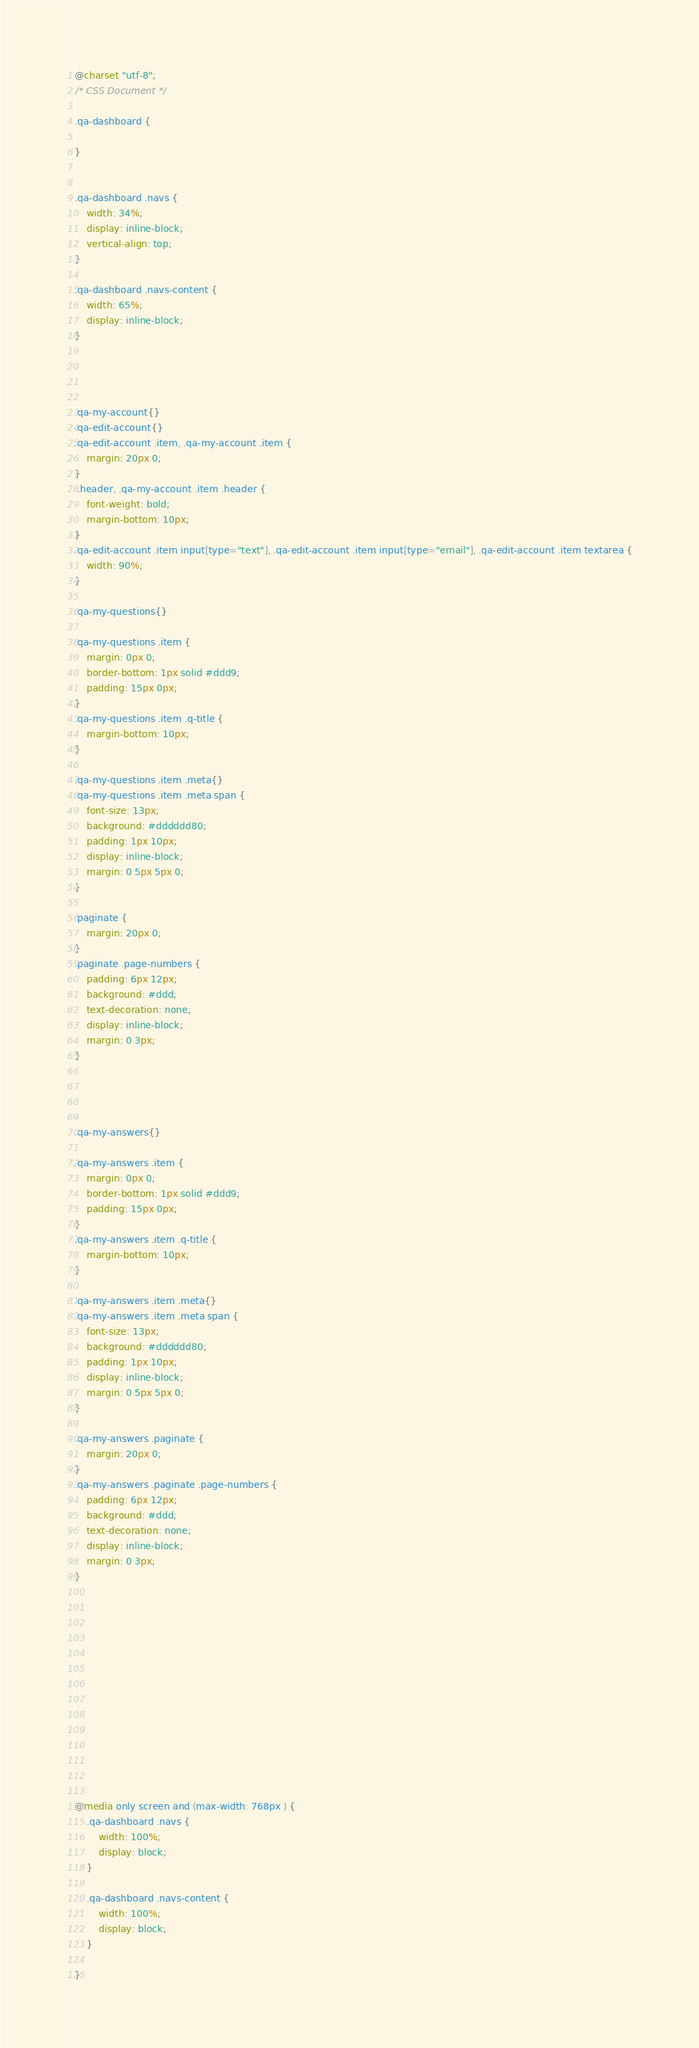<code> <loc_0><loc_0><loc_500><loc_500><_CSS_>@charset "utf-8";
/* CSS Document */

.qa-dashboard {

}


.qa-dashboard .navs {
    width: 34%;
    display: inline-block;
    vertical-align: top;
}

.qa-dashboard .navs-content {
    width: 65%;
    display: inline-block;
}




.qa-my-account{}
.qa-edit-account{}
.qa-edit-account .item, .qa-my-account .item {
    margin: 20px 0;
}
 .header, .qa-my-account .item .header {
    font-weight: bold;
    margin-bottom: 10px;
}
.qa-edit-account .item input[type="text"], .qa-edit-account .item input[type="email"], .qa-edit-account .item textarea {
    width: 90%;
}

.qa-my-questions{}

.qa-my-questions .item {
    margin: 0px 0;
    border-bottom: 1px solid #ddd9;
    padding: 15px 0px;
}
.qa-my-questions .item .q-title {
    margin-bottom: 10px;
}

.qa-my-questions .item .meta{}
.qa-my-questions .item .meta span {
    font-size: 13px;
    background: #dddddd80;
    padding: 1px 10px;
    display: inline-block;
    margin: 0 5px 5px 0;
}

.paginate {
    margin: 20px 0;
}
.paginate .page-numbers {
    padding: 6px 12px;
    background: #ddd;
    text-decoration: none;
    display: inline-block;
    margin: 0 3px;
}




.qa-my-answers{}

.qa-my-answers .item {
    margin: 0px 0;
    border-bottom: 1px solid #ddd9;
    padding: 15px 0px;
}
.qa-my-answers .item .q-title {
    margin-bottom: 10px;
}

.qa-my-answers .item .meta{}
.qa-my-answers .item .meta span {
    font-size: 13px;
    background: #dddddd80;
    padding: 1px 10px;
    display: inline-block;
    margin: 0 5px 5px 0;
}

.qa-my-answers .paginate {
    margin: 20px 0;
}
.qa-my-answers .paginate .page-numbers {
    padding: 6px 12px;
    background: #ddd;
    text-decoration: none;
    display: inline-block;
    margin: 0 3px;
}














@media only screen and (max-width: 768px ) {
    .qa-dashboard .navs {
        width: 100%;
        display: block;
    }

    .qa-dashboard .navs-content {
        width: 100%;
        display: block;
    }

}








</code> 